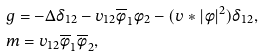Convert formula to latex. <formula><loc_0><loc_0><loc_500><loc_500>& g = - \Delta \delta _ { 1 2 } - v _ { 1 2 } \overline { \phi } _ { 1 } \phi _ { 2 } - ( v * | \phi | ^ { 2 } ) \delta _ { 1 2 } , \\ & m = v _ { 1 2 } \overline { \phi } _ { 1 } \overline { \phi } _ { 2 } ,</formula> 